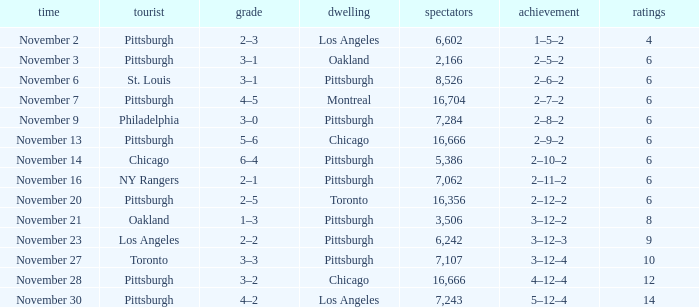What is the lowest amount of points of the game with toronto as the home team? 6.0. 